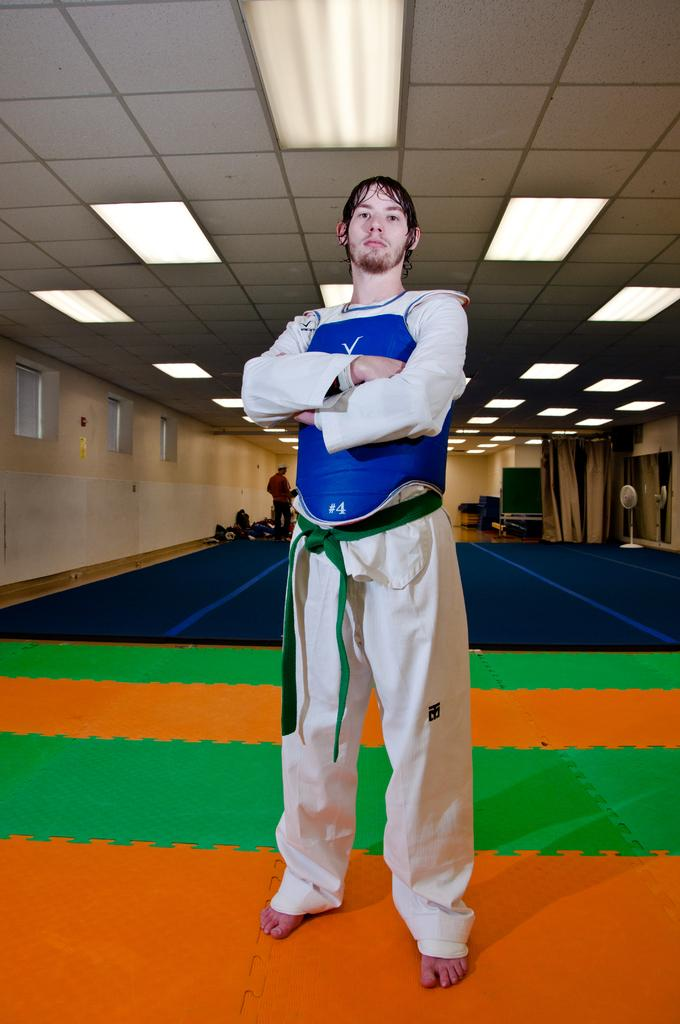What is located in the foreground of the image? There is a person and a mat in the foreground of the image. What can be seen above the person in the image? There is a ceiling visible in the image. What is present in the background of the image? There are curtains, a wall, windows, a fan, and another person in the background of the image. Can you describe the objects in the background of the image? There are other objects in the background of the image, but their specific details are not mentioned in the provided facts. What type of straw is being used to create a boundary around the person in the image? There is no straw or boundary present in the image; it features a person and a mat in the foreground. Is there a quilt visible in the image? There is no mention of a quilt in the provided facts, so it cannot be determined if one is present in the image. 